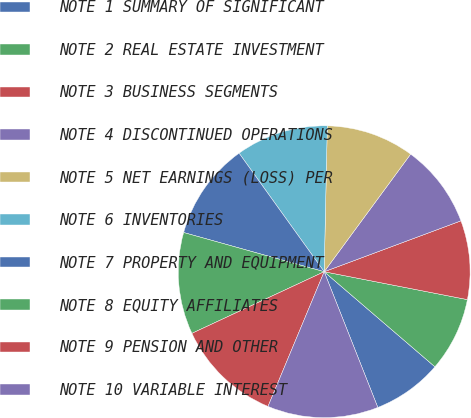<chart> <loc_0><loc_0><loc_500><loc_500><pie_chart><fcel>NOTE 1 SUMMARY OF SIGNIFICANT<fcel>NOTE 2 REAL ESTATE INVESTMENT<fcel>NOTE 3 BUSINESS SEGMENTS<fcel>NOTE 4 DISCONTINUED OPERATIONS<fcel>NOTE 5 NET EARNINGS (LOSS) PER<fcel>NOTE 6 INVENTORIES<fcel>NOTE 7 PROPERTY AND EQUIPMENT<fcel>NOTE 8 EQUITY AFFILIATES<fcel>NOTE 9 PENSION AND OTHER<fcel>NOTE 10 VARIABLE INTEREST<nl><fcel>7.72%<fcel>8.23%<fcel>8.73%<fcel>9.24%<fcel>9.75%<fcel>10.25%<fcel>10.76%<fcel>11.27%<fcel>11.77%<fcel>12.28%<nl></chart> 